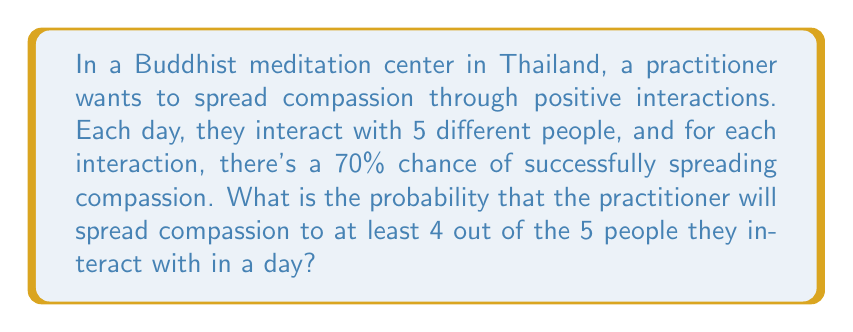Could you help me with this problem? To solve this problem, we'll use the binomial probability distribution, as we have a fixed number of independent trials (interactions) with two possible outcomes (success or failure in spreading compassion).

Let's define our variables:
$n = 5$ (number of interactions)
$p = 0.7$ (probability of success for each interaction)
$q = 1 - p = 0.3$ (probability of failure for each interaction)

We want to find the probability of at least 4 successes, which means we need to calculate the probability of exactly 4 successes plus the probability of exactly 5 successes.

The binomial probability formula is:

$P(X = k) = \binom{n}{k} p^k q^{n-k}$

Where $\binom{n}{k}$ is the binomial coefficient, calculated as:

$\binom{n}{k} = \frac{n!}{k!(n-k)!}$

For 4 successes:
$P(X = 4) = \binom{5}{4} (0.7)^4 (0.3)^1$
$= 5 \cdot (0.7)^4 \cdot (0.3)^1$
$= 5 \cdot 0.2401 \cdot 0.3$
$= 0.36015$

For 5 successes:
$P(X = 5) = \binom{5}{5} (0.7)^5 (0.3)^0$
$= 1 \cdot (0.7)^5 \cdot 1$
$= 0.16807$

The probability of at least 4 successes is the sum of these two probabilities:

$P(X \geq 4) = P(X = 4) + P(X = 5)$
$= 0.36015 + 0.16807$
$= 0.52822$
Answer: The probability that the Buddhist practitioner will spread compassion to at least 4 out of 5 people in a day is approximately 0.52822 or 52.822%. 